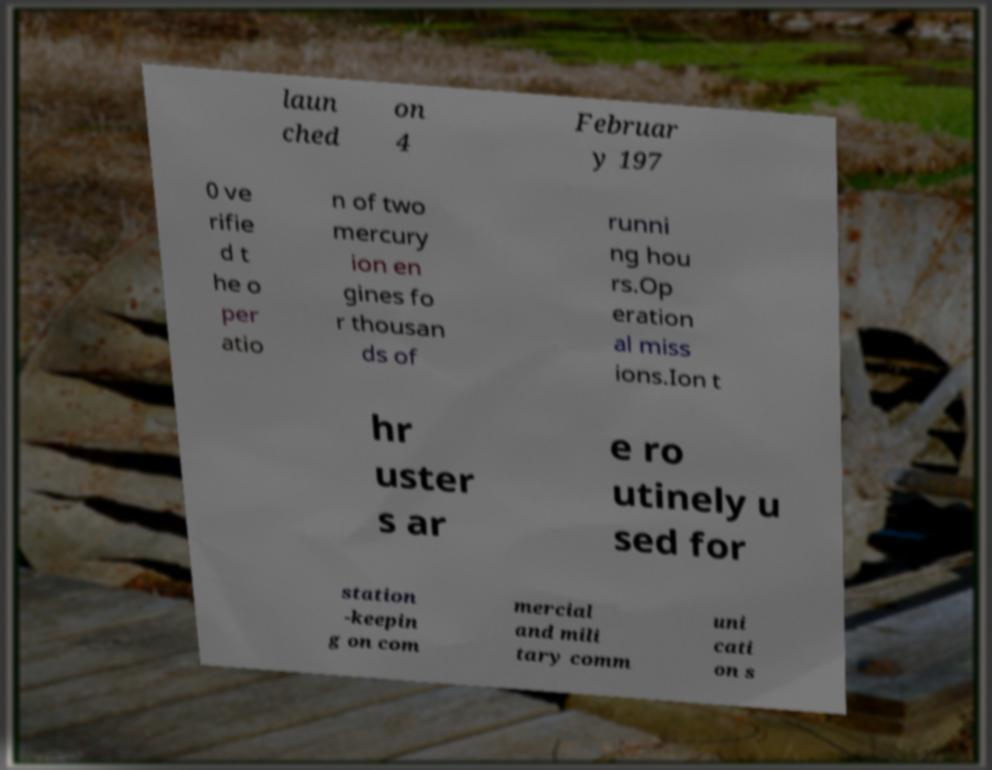Please identify and transcribe the text found in this image. laun ched on 4 Februar y 197 0 ve rifie d t he o per atio n of two mercury ion en gines fo r thousan ds of runni ng hou rs.Op eration al miss ions.Ion t hr uster s ar e ro utinely u sed for station -keepin g on com mercial and mili tary comm uni cati on s 